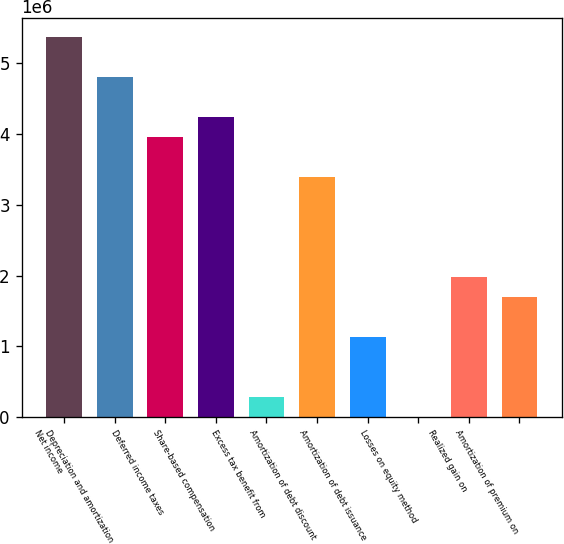Convert chart. <chart><loc_0><loc_0><loc_500><loc_500><bar_chart><fcel>Net income<fcel>Depreciation and amortization<fcel>Deferred income taxes<fcel>Share-based compensation<fcel>Excess tax benefit from<fcel>Amortization of debt discount<fcel>Amortization of debt issuance<fcel>Losses on equity method<fcel>Realized gain on<fcel>Amortization of premium on<nl><fcel>5.36573e+06<fcel>4.80095e+06<fcel>3.95379e+06<fcel>4.23617e+06<fcel>282734<fcel>3.38901e+06<fcel>1.1299e+06<fcel>345<fcel>1.97707e+06<fcel>1.69468e+06<nl></chart> 